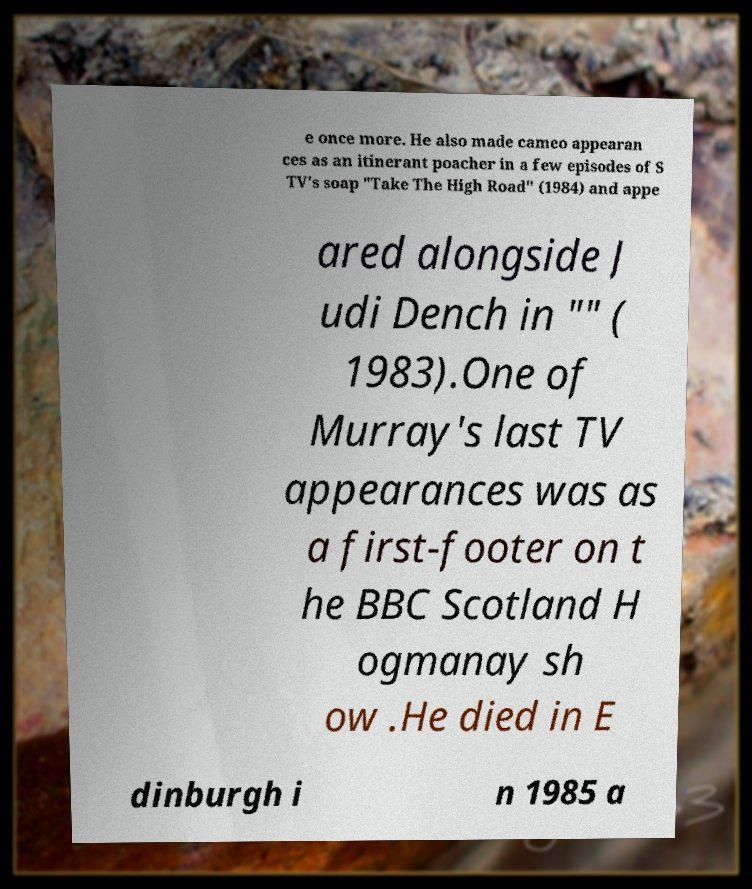Please read and relay the text visible in this image. What does it say? e once more. He also made cameo appearan ces as an itinerant poacher in a few episodes of S TV's soap "Take The High Road" (1984) and appe ared alongside J udi Dench in "" ( 1983).One of Murray's last TV appearances was as a first-footer on t he BBC Scotland H ogmanay sh ow .He died in E dinburgh i n 1985 a 